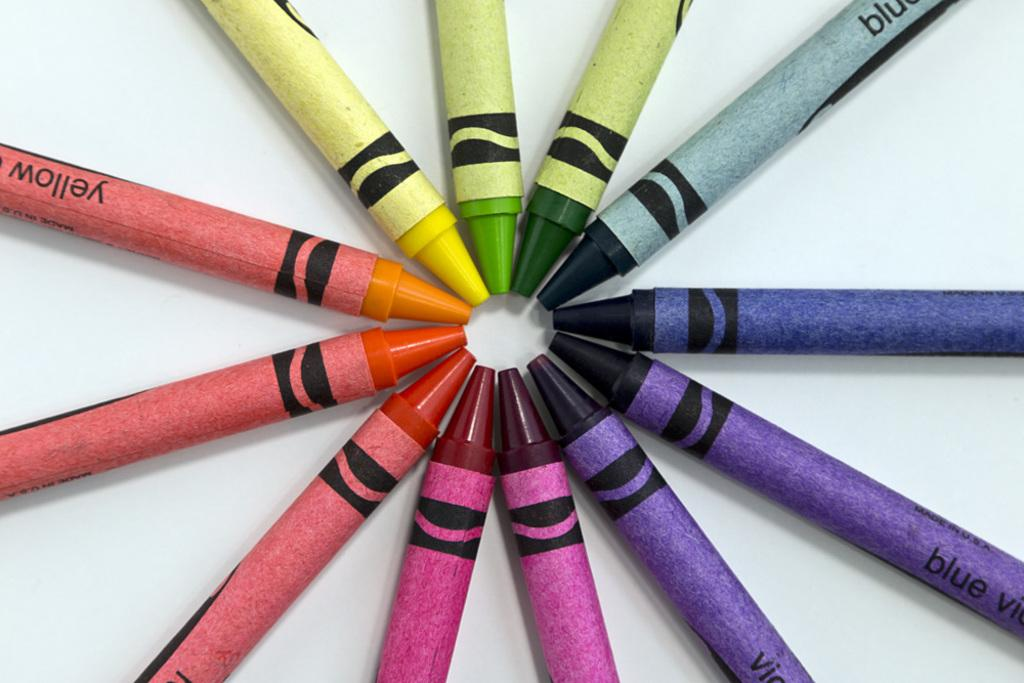<image>
Describe the image concisely. Crayons are arranged in a circle including one that says yellow on the label. 